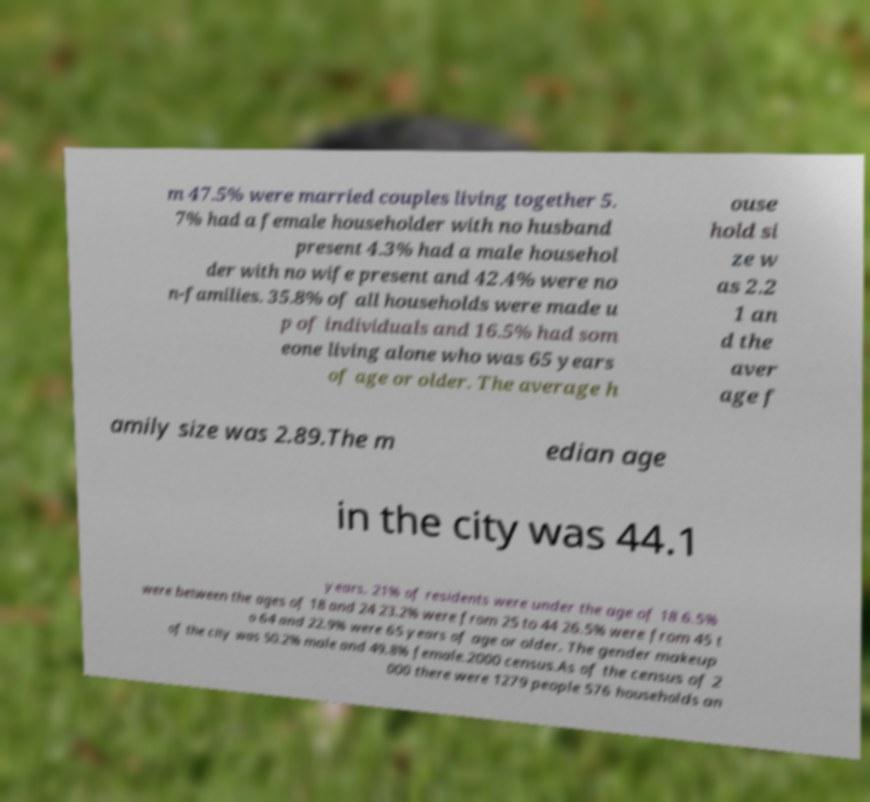Can you read and provide the text displayed in the image?This photo seems to have some interesting text. Can you extract and type it out for me? m 47.5% were married couples living together 5. 7% had a female householder with no husband present 4.3% had a male househol der with no wife present and 42.4% were no n-families. 35.8% of all households were made u p of individuals and 16.5% had som eone living alone who was 65 years of age or older. The average h ouse hold si ze w as 2.2 1 an d the aver age f amily size was 2.89.The m edian age in the city was 44.1 years. 21% of residents were under the age of 18 6.5% were between the ages of 18 and 24 23.2% were from 25 to 44 26.5% were from 45 t o 64 and 22.9% were 65 years of age or older. The gender makeup of the city was 50.2% male and 49.8% female.2000 census.As of the census of 2 000 there were 1279 people 576 households an 